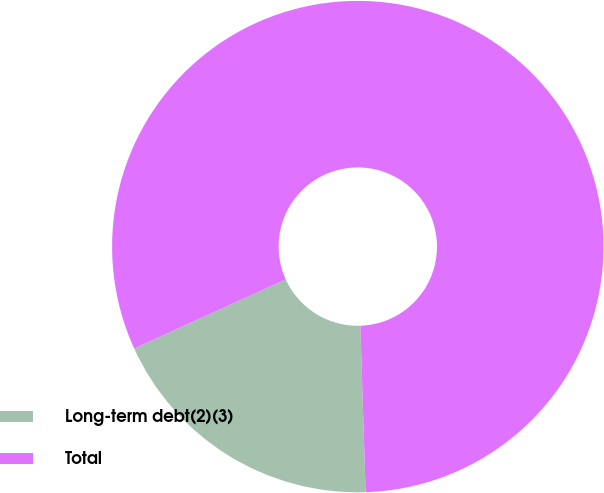<chart> <loc_0><loc_0><loc_500><loc_500><pie_chart><fcel>Long-term debt(2)(3)<fcel>Total<nl><fcel>18.7%<fcel>81.3%<nl></chart> 